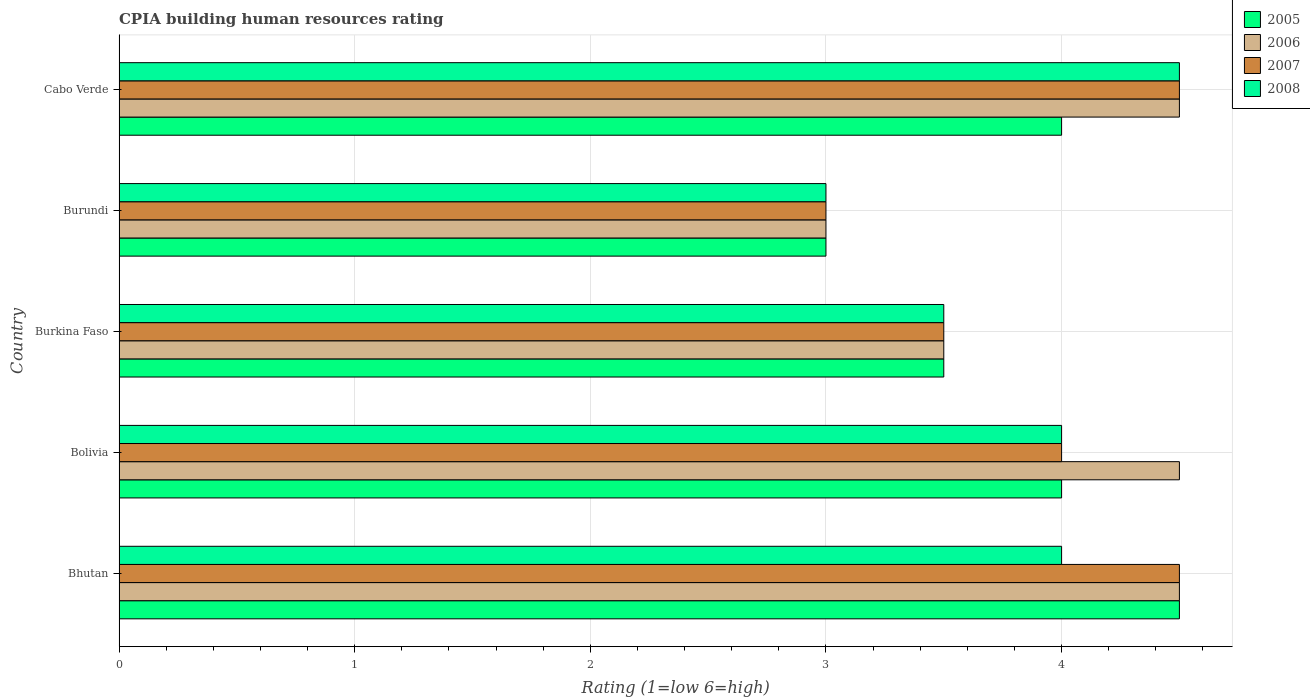What is the label of the 2nd group of bars from the top?
Give a very brief answer. Burundi. What is the CPIA rating in 2005 in Burkina Faso?
Provide a short and direct response. 3.5. In which country was the CPIA rating in 2007 maximum?
Your answer should be compact. Bhutan. In which country was the CPIA rating in 2007 minimum?
Keep it short and to the point. Burundi. What is the total CPIA rating in 2008 in the graph?
Offer a terse response. 19. What is the difference between the CPIA rating in 2007 in Bolivia and the CPIA rating in 2005 in Bhutan?
Your response must be concise. -0.5. In how many countries, is the CPIA rating in 2008 greater than 1.4 ?
Offer a very short reply. 5. What is the ratio of the CPIA rating in 2007 in Bolivia to that in Burkina Faso?
Offer a terse response. 1.14. How many bars are there?
Make the answer very short. 20. Are all the bars in the graph horizontal?
Offer a very short reply. Yes. What is the difference between two consecutive major ticks on the X-axis?
Provide a short and direct response. 1. Are the values on the major ticks of X-axis written in scientific E-notation?
Provide a short and direct response. No. Where does the legend appear in the graph?
Offer a terse response. Top right. How many legend labels are there?
Your response must be concise. 4. What is the title of the graph?
Your answer should be very brief. CPIA building human resources rating. Does "1989" appear as one of the legend labels in the graph?
Your answer should be very brief. No. What is the Rating (1=low 6=high) of 2005 in Bhutan?
Provide a succinct answer. 4.5. What is the Rating (1=low 6=high) in 2008 in Bhutan?
Your answer should be very brief. 4. What is the Rating (1=low 6=high) of 2005 in Bolivia?
Make the answer very short. 4. What is the Rating (1=low 6=high) of 2006 in Bolivia?
Provide a succinct answer. 4.5. What is the Rating (1=low 6=high) of 2007 in Bolivia?
Make the answer very short. 4. What is the Rating (1=low 6=high) of 2005 in Burkina Faso?
Ensure brevity in your answer.  3.5. What is the Rating (1=low 6=high) of 2007 in Burkina Faso?
Provide a short and direct response. 3.5. What is the Rating (1=low 6=high) of 2005 in Burundi?
Your answer should be compact. 3. What is the Rating (1=low 6=high) in 2006 in Burundi?
Ensure brevity in your answer.  3. What is the Rating (1=low 6=high) of 2008 in Burundi?
Provide a succinct answer. 3. What is the Rating (1=low 6=high) of 2005 in Cabo Verde?
Give a very brief answer. 4. What is the Rating (1=low 6=high) of 2006 in Cabo Verde?
Make the answer very short. 4.5. Across all countries, what is the maximum Rating (1=low 6=high) in 2008?
Your answer should be very brief. 4.5. Across all countries, what is the minimum Rating (1=low 6=high) of 2007?
Offer a terse response. 3. Across all countries, what is the minimum Rating (1=low 6=high) in 2008?
Offer a terse response. 3. What is the total Rating (1=low 6=high) of 2007 in the graph?
Your answer should be very brief. 19.5. What is the difference between the Rating (1=low 6=high) in 2006 in Bhutan and that in Bolivia?
Your answer should be compact. 0. What is the difference between the Rating (1=low 6=high) of 2007 in Bhutan and that in Bolivia?
Offer a terse response. 0.5. What is the difference between the Rating (1=low 6=high) in 2008 in Bhutan and that in Bolivia?
Offer a very short reply. 0. What is the difference between the Rating (1=low 6=high) in 2005 in Bhutan and that in Burkina Faso?
Keep it short and to the point. 1. What is the difference between the Rating (1=low 6=high) in 2007 in Bhutan and that in Burkina Faso?
Ensure brevity in your answer.  1. What is the difference between the Rating (1=low 6=high) of 2008 in Bhutan and that in Burkina Faso?
Provide a short and direct response. 0.5. What is the difference between the Rating (1=low 6=high) in 2005 in Bhutan and that in Burundi?
Keep it short and to the point. 1.5. What is the difference between the Rating (1=low 6=high) in 2007 in Bhutan and that in Burundi?
Your response must be concise. 1.5. What is the difference between the Rating (1=low 6=high) of 2008 in Bhutan and that in Burundi?
Your response must be concise. 1. What is the difference between the Rating (1=low 6=high) in 2005 in Bhutan and that in Cabo Verde?
Offer a terse response. 0.5. What is the difference between the Rating (1=low 6=high) in 2007 in Bhutan and that in Cabo Verde?
Your answer should be very brief. 0. What is the difference between the Rating (1=low 6=high) of 2006 in Bolivia and that in Burkina Faso?
Your response must be concise. 1. What is the difference between the Rating (1=low 6=high) of 2008 in Bolivia and that in Burkina Faso?
Your response must be concise. 0.5. What is the difference between the Rating (1=low 6=high) of 2005 in Bolivia and that in Burundi?
Offer a very short reply. 1. What is the difference between the Rating (1=low 6=high) in 2006 in Bolivia and that in Cabo Verde?
Provide a short and direct response. 0. What is the difference between the Rating (1=low 6=high) in 2007 in Bolivia and that in Cabo Verde?
Provide a short and direct response. -0.5. What is the difference between the Rating (1=low 6=high) in 2006 in Burkina Faso and that in Burundi?
Offer a terse response. 0.5. What is the difference between the Rating (1=low 6=high) in 2007 in Burkina Faso and that in Burundi?
Make the answer very short. 0.5. What is the difference between the Rating (1=low 6=high) of 2005 in Burkina Faso and that in Cabo Verde?
Give a very brief answer. -0.5. What is the difference between the Rating (1=low 6=high) in 2007 in Burkina Faso and that in Cabo Verde?
Keep it short and to the point. -1. What is the difference between the Rating (1=low 6=high) in 2005 in Burundi and that in Cabo Verde?
Offer a terse response. -1. What is the difference between the Rating (1=low 6=high) of 2006 in Burundi and that in Cabo Verde?
Your response must be concise. -1.5. What is the difference between the Rating (1=low 6=high) in 2005 in Bhutan and the Rating (1=low 6=high) in 2006 in Bolivia?
Provide a short and direct response. 0. What is the difference between the Rating (1=low 6=high) of 2005 in Bhutan and the Rating (1=low 6=high) of 2007 in Bolivia?
Offer a very short reply. 0.5. What is the difference between the Rating (1=low 6=high) of 2005 in Bhutan and the Rating (1=low 6=high) of 2008 in Bolivia?
Your response must be concise. 0.5. What is the difference between the Rating (1=low 6=high) of 2006 in Bhutan and the Rating (1=low 6=high) of 2008 in Bolivia?
Offer a very short reply. 0.5. What is the difference between the Rating (1=low 6=high) in 2007 in Bhutan and the Rating (1=low 6=high) in 2008 in Bolivia?
Offer a terse response. 0.5. What is the difference between the Rating (1=low 6=high) in 2005 in Bhutan and the Rating (1=low 6=high) in 2008 in Burkina Faso?
Give a very brief answer. 1. What is the difference between the Rating (1=low 6=high) of 2007 in Bhutan and the Rating (1=low 6=high) of 2008 in Burkina Faso?
Your answer should be very brief. 1. What is the difference between the Rating (1=low 6=high) in 2007 in Bhutan and the Rating (1=low 6=high) in 2008 in Burundi?
Give a very brief answer. 1.5. What is the difference between the Rating (1=low 6=high) of 2005 in Bhutan and the Rating (1=low 6=high) of 2008 in Cabo Verde?
Ensure brevity in your answer.  0. What is the difference between the Rating (1=low 6=high) of 2006 in Bhutan and the Rating (1=low 6=high) of 2007 in Cabo Verde?
Provide a short and direct response. 0. What is the difference between the Rating (1=low 6=high) of 2005 in Bolivia and the Rating (1=low 6=high) of 2006 in Burkina Faso?
Keep it short and to the point. 0.5. What is the difference between the Rating (1=low 6=high) in 2006 in Bolivia and the Rating (1=low 6=high) in 2008 in Burkina Faso?
Provide a short and direct response. 1. What is the difference between the Rating (1=low 6=high) of 2005 in Bolivia and the Rating (1=low 6=high) of 2007 in Burundi?
Offer a very short reply. 1. What is the difference between the Rating (1=low 6=high) of 2005 in Bolivia and the Rating (1=low 6=high) of 2008 in Burundi?
Your response must be concise. 1. What is the difference between the Rating (1=low 6=high) in 2006 in Bolivia and the Rating (1=low 6=high) in 2007 in Burundi?
Your response must be concise. 1.5. What is the difference between the Rating (1=low 6=high) of 2005 in Bolivia and the Rating (1=low 6=high) of 2006 in Cabo Verde?
Give a very brief answer. -0.5. What is the difference between the Rating (1=low 6=high) of 2007 in Bolivia and the Rating (1=low 6=high) of 2008 in Cabo Verde?
Provide a succinct answer. -0.5. What is the difference between the Rating (1=low 6=high) of 2005 in Burkina Faso and the Rating (1=low 6=high) of 2007 in Burundi?
Provide a succinct answer. 0.5. What is the difference between the Rating (1=low 6=high) in 2006 in Burkina Faso and the Rating (1=low 6=high) in 2007 in Burundi?
Give a very brief answer. 0.5. What is the difference between the Rating (1=low 6=high) in 2005 in Burkina Faso and the Rating (1=low 6=high) in 2008 in Cabo Verde?
Provide a short and direct response. -1. What is the difference between the Rating (1=low 6=high) in 2005 in Burundi and the Rating (1=low 6=high) in 2006 in Cabo Verde?
Your response must be concise. -1.5. What is the difference between the Rating (1=low 6=high) of 2005 in Burundi and the Rating (1=low 6=high) of 2007 in Cabo Verde?
Make the answer very short. -1.5. What is the difference between the Rating (1=low 6=high) of 2006 in Burundi and the Rating (1=low 6=high) of 2007 in Cabo Verde?
Ensure brevity in your answer.  -1.5. What is the difference between the Rating (1=low 6=high) of 2006 in Burundi and the Rating (1=low 6=high) of 2008 in Cabo Verde?
Your response must be concise. -1.5. What is the difference between the Rating (1=low 6=high) of 2007 in Burundi and the Rating (1=low 6=high) of 2008 in Cabo Verde?
Give a very brief answer. -1.5. What is the average Rating (1=low 6=high) in 2005 per country?
Your response must be concise. 3.8. What is the average Rating (1=low 6=high) in 2006 per country?
Make the answer very short. 4. What is the average Rating (1=low 6=high) in 2007 per country?
Keep it short and to the point. 3.9. What is the average Rating (1=low 6=high) of 2008 per country?
Offer a terse response. 3.8. What is the difference between the Rating (1=low 6=high) in 2005 and Rating (1=low 6=high) in 2008 in Bhutan?
Offer a very short reply. 0.5. What is the difference between the Rating (1=low 6=high) in 2006 and Rating (1=low 6=high) in 2007 in Bhutan?
Your answer should be compact. 0. What is the difference between the Rating (1=low 6=high) in 2005 and Rating (1=low 6=high) in 2006 in Bolivia?
Provide a short and direct response. -0.5. What is the difference between the Rating (1=low 6=high) of 2005 and Rating (1=low 6=high) of 2008 in Bolivia?
Give a very brief answer. 0. What is the difference between the Rating (1=low 6=high) of 2006 and Rating (1=low 6=high) of 2007 in Bolivia?
Give a very brief answer. 0.5. What is the difference between the Rating (1=low 6=high) of 2006 and Rating (1=low 6=high) of 2008 in Bolivia?
Provide a short and direct response. 0.5. What is the difference between the Rating (1=low 6=high) in 2007 and Rating (1=low 6=high) in 2008 in Bolivia?
Provide a succinct answer. 0. What is the difference between the Rating (1=low 6=high) in 2005 and Rating (1=low 6=high) in 2006 in Burkina Faso?
Make the answer very short. 0. What is the difference between the Rating (1=low 6=high) in 2005 and Rating (1=low 6=high) in 2007 in Burkina Faso?
Offer a terse response. 0. What is the difference between the Rating (1=low 6=high) of 2006 and Rating (1=low 6=high) of 2008 in Burkina Faso?
Your response must be concise. 0. What is the difference between the Rating (1=low 6=high) of 2007 and Rating (1=low 6=high) of 2008 in Burkina Faso?
Offer a terse response. 0. What is the difference between the Rating (1=low 6=high) of 2005 and Rating (1=low 6=high) of 2006 in Burundi?
Give a very brief answer. 0. What is the difference between the Rating (1=low 6=high) in 2005 and Rating (1=low 6=high) in 2008 in Burundi?
Keep it short and to the point. 0. What is the difference between the Rating (1=low 6=high) of 2006 and Rating (1=low 6=high) of 2007 in Burundi?
Give a very brief answer. 0. What is the difference between the Rating (1=low 6=high) in 2006 and Rating (1=low 6=high) in 2008 in Burundi?
Your answer should be very brief. 0. What is the difference between the Rating (1=low 6=high) of 2005 and Rating (1=low 6=high) of 2007 in Cabo Verde?
Provide a succinct answer. -0.5. What is the difference between the Rating (1=low 6=high) in 2005 and Rating (1=low 6=high) in 2008 in Cabo Verde?
Provide a succinct answer. -0.5. What is the difference between the Rating (1=low 6=high) of 2006 and Rating (1=low 6=high) of 2008 in Cabo Verde?
Provide a succinct answer. 0. What is the ratio of the Rating (1=low 6=high) of 2005 in Bhutan to that in Bolivia?
Keep it short and to the point. 1.12. What is the ratio of the Rating (1=low 6=high) of 2006 in Bhutan to that in Bolivia?
Provide a short and direct response. 1. What is the ratio of the Rating (1=low 6=high) in 2008 in Bhutan to that in Bolivia?
Give a very brief answer. 1. What is the ratio of the Rating (1=low 6=high) in 2006 in Bhutan to that in Burkina Faso?
Your response must be concise. 1.29. What is the ratio of the Rating (1=low 6=high) in 2007 in Bhutan to that in Burkina Faso?
Provide a short and direct response. 1.29. What is the ratio of the Rating (1=low 6=high) of 2008 in Bhutan to that in Burkina Faso?
Offer a terse response. 1.14. What is the ratio of the Rating (1=low 6=high) in 2005 in Bhutan to that in Burundi?
Offer a very short reply. 1.5. What is the ratio of the Rating (1=low 6=high) in 2007 in Bhutan to that in Burundi?
Your response must be concise. 1.5. What is the ratio of the Rating (1=low 6=high) of 2008 in Bhutan to that in Burundi?
Keep it short and to the point. 1.33. What is the ratio of the Rating (1=low 6=high) in 2005 in Bhutan to that in Cabo Verde?
Your response must be concise. 1.12. What is the ratio of the Rating (1=low 6=high) in 2006 in Bhutan to that in Cabo Verde?
Your answer should be compact. 1. What is the ratio of the Rating (1=low 6=high) of 2007 in Bhutan to that in Cabo Verde?
Ensure brevity in your answer.  1. What is the ratio of the Rating (1=low 6=high) of 2005 in Bolivia to that in Burkina Faso?
Provide a short and direct response. 1.14. What is the ratio of the Rating (1=low 6=high) in 2006 in Bolivia to that in Burkina Faso?
Give a very brief answer. 1.29. What is the ratio of the Rating (1=low 6=high) of 2007 in Bolivia to that in Burkina Faso?
Keep it short and to the point. 1.14. What is the ratio of the Rating (1=low 6=high) in 2008 in Bolivia to that in Burkina Faso?
Offer a terse response. 1.14. What is the ratio of the Rating (1=low 6=high) of 2005 in Bolivia to that in Cabo Verde?
Your response must be concise. 1. What is the ratio of the Rating (1=low 6=high) of 2006 in Bolivia to that in Cabo Verde?
Ensure brevity in your answer.  1. What is the ratio of the Rating (1=low 6=high) of 2007 in Bolivia to that in Cabo Verde?
Make the answer very short. 0.89. What is the ratio of the Rating (1=low 6=high) in 2006 in Burkina Faso to that in Burundi?
Keep it short and to the point. 1.17. What is the ratio of the Rating (1=low 6=high) of 2007 in Burkina Faso to that in Burundi?
Offer a very short reply. 1.17. What is the ratio of the Rating (1=low 6=high) in 2008 in Burkina Faso to that in Burundi?
Your answer should be very brief. 1.17. What is the ratio of the Rating (1=low 6=high) in 2008 in Burkina Faso to that in Cabo Verde?
Provide a short and direct response. 0.78. What is the ratio of the Rating (1=low 6=high) of 2005 in Burundi to that in Cabo Verde?
Your answer should be compact. 0.75. What is the ratio of the Rating (1=low 6=high) of 2006 in Burundi to that in Cabo Verde?
Your answer should be very brief. 0.67. What is the difference between the highest and the second highest Rating (1=low 6=high) in 2006?
Keep it short and to the point. 0. What is the difference between the highest and the second highest Rating (1=low 6=high) of 2007?
Ensure brevity in your answer.  0. What is the difference between the highest and the lowest Rating (1=low 6=high) of 2007?
Give a very brief answer. 1.5. What is the difference between the highest and the lowest Rating (1=low 6=high) in 2008?
Make the answer very short. 1.5. 